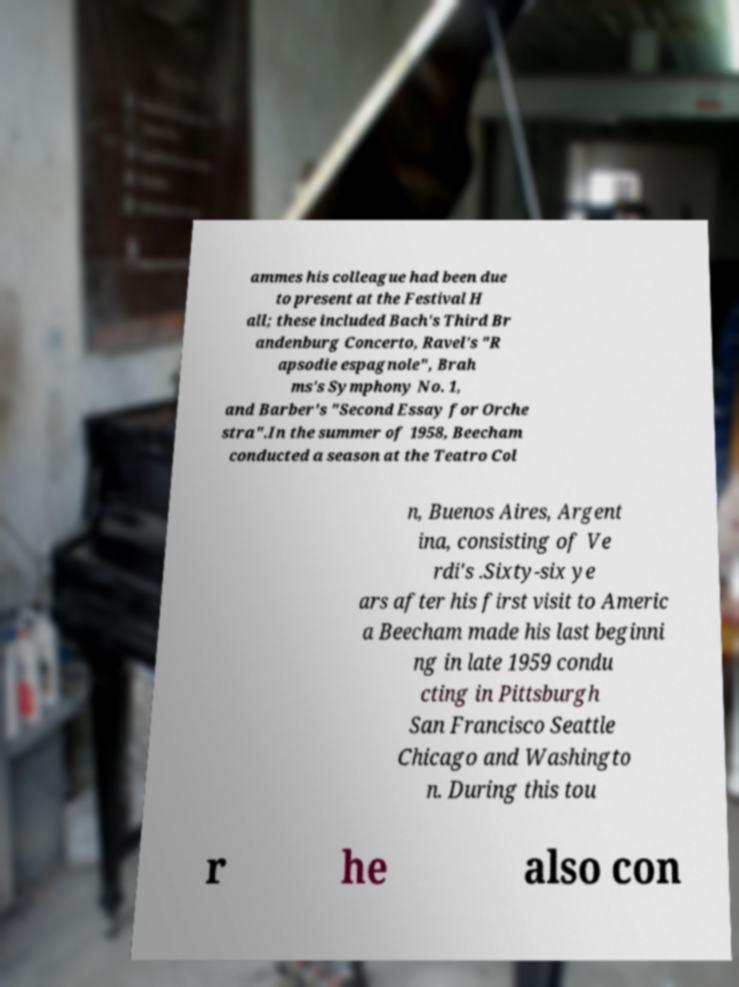Can you read and provide the text displayed in the image?This photo seems to have some interesting text. Can you extract and type it out for me? ammes his colleague had been due to present at the Festival H all; these included Bach's Third Br andenburg Concerto, Ravel's "R apsodie espagnole", Brah ms's Symphony No. 1, and Barber's "Second Essay for Orche stra".In the summer of 1958, Beecham conducted a season at the Teatro Col n, Buenos Aires, Argent ina, consisting of Ve rdi's .Sixty-six ye ars after his first visit to Americ a Beecham made his last beginni ng in late 1959 condu cting in Pittsburgh San Francisco Seattle Chicago and Washingto n. During this tou r he also con 